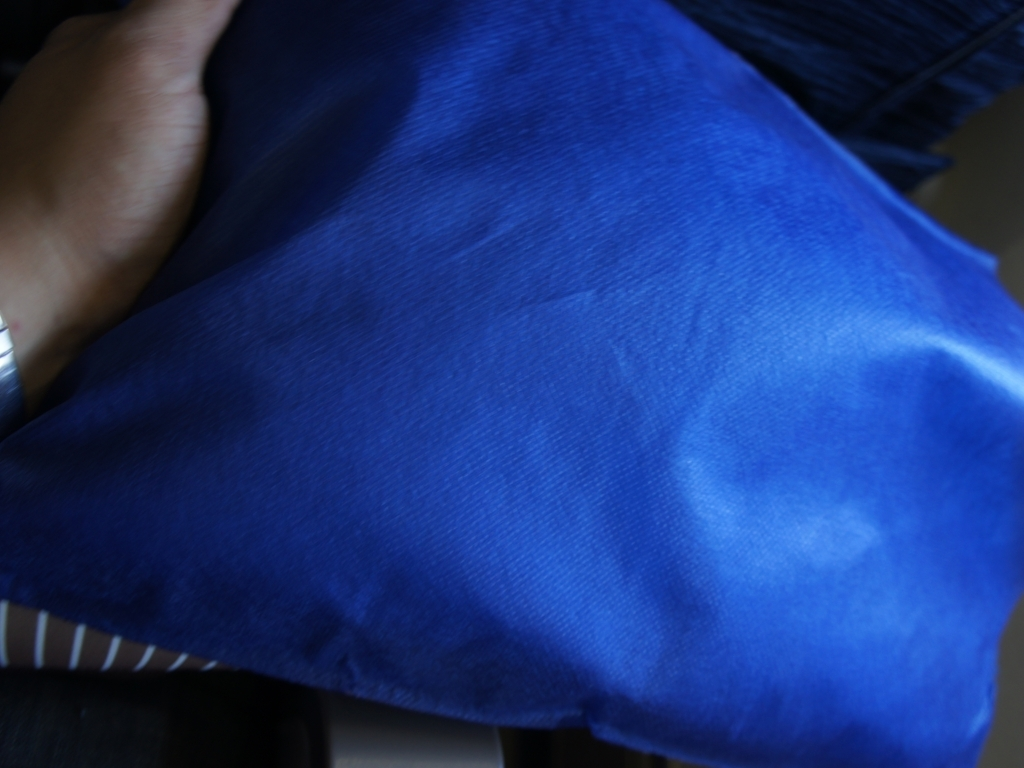Can you describe the object that appears to be the focal point of this image? The image displays a hand holding a blue pillow or cushion with a visible textured surface. The cushion seems to be the main subject due to its central position and the way it contrasts with the indistinct background. Does the texture of the fabric indicate any specific material or use? The fabric has a pronounced woven texture, suggesting it could be made of a material like cotton or linen. These materials are commonly used in home decor for their comfort and aesthetic appeal. 